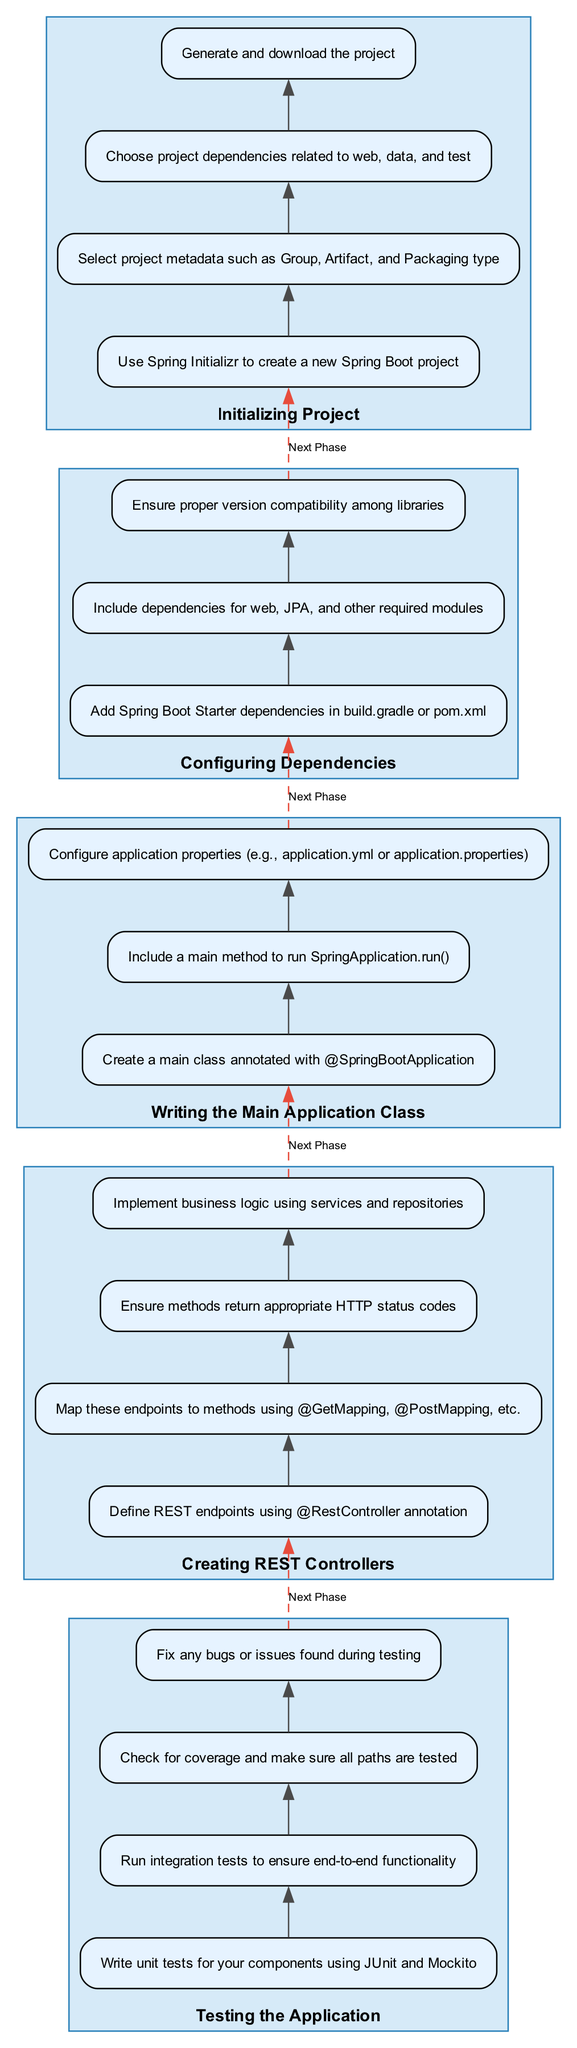What is the first phase in setting up a Spring Boot application? The first phase is "Initializing Project" as it appears at the bottom of the flow chart.
Answer: Initializing Project How many steps are there in the "Creating REST Controllers" phase? The phase "Creating REST Controllers" has four steps, outlined within the box representing that phase.
Answer: Four What does the last step of the "Testing the Application" phase involve? The last step of the "Testing the Application" phase is "Fix any bugs or issues found during testing".
Answer: Fix any bugs or issues found during testing Which phase comes immediately before "Testing the Application"? Before "Testing the Application", the phase "Creating REST Controllers" is present as indicated by the dashed edge connecting them.
Answer: Creating REST Controllers What annotation is primarily used to define REST endpoints in the corresponding phase? "Define REST endpoints using @RestController annotation" is the specified action in the "Creating REST Controllers" phase, indicating the main annotation used.
Answer: @RestController annotation In which phase is the main class created? The creation of the main class occurs in the "Writing the Main Application Class" phase, as it is explicitly mentioned in the steps within that phase.
Answer: Writing the Main Application Class Which annotation is used to denote the main application class? The annotation specified for the main application class is "@SpringBootApplication", found in the corresponding phase detailing its creation.
Answer: @SpringBootApplication How many phases are listed in the diagram overall? There are a total of five phases outlined in the diagram, each represented in the respective sections moving upwards.
Answer: Five What is the shared focus of the steps within the "Configuring Dependencies" phase? The shared focus is on adding and managing necessary dependencies for the Spring Boot project, as indicated by the steps listed in that phase.
Answer: Adding and managing necessary dependencies 